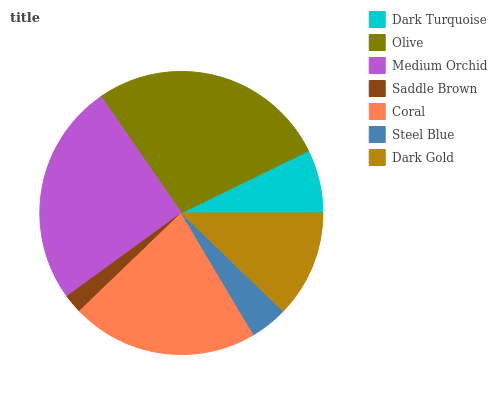Is Saddle Brown the minimum?
Answer yes or no. Yes. Is Olive the maximum?
Answer yes or no. Yes. Is Medium Orchid the minimum?
Answer yes or no. No. Is Medium Orchid the maximum?
Answer yes or no. No. Is Olive greater than Medium Orchid?
Answer yes or no. Yes. Is Medium Orchid less than Olive?
Answer yes or no. Yes. Is Medium Orchid greater than Olive?
Answer yes or no. No. Is Olive less than Medium Orchid?
Answer yes or no. No. Is Dark Gold the high median?
Answer yes or no. Yes. Is Dark Gold the low median?
Answer yes or no. Yes. Is Dark Turquoise the high median?
Answer yes or no. No. Is Steel Blue the low median?
Answer yes or no. No. 